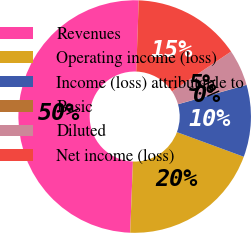Convert chart. <chart><loc_0><loc_0><loc_500><loc_500><pie_chart><fcel>Revenues<fcel>Operating income (loss)<fcel>Income (loss) attributable to<fcel>Basic<fcel>Diluted<fcel>Net income (loss)<nl><fcel>49.93%<fcel>19.99%<fcel>10.01%<fcel>0.03%<fcel>5.02%<fcel>15.0%<nl></chart> 